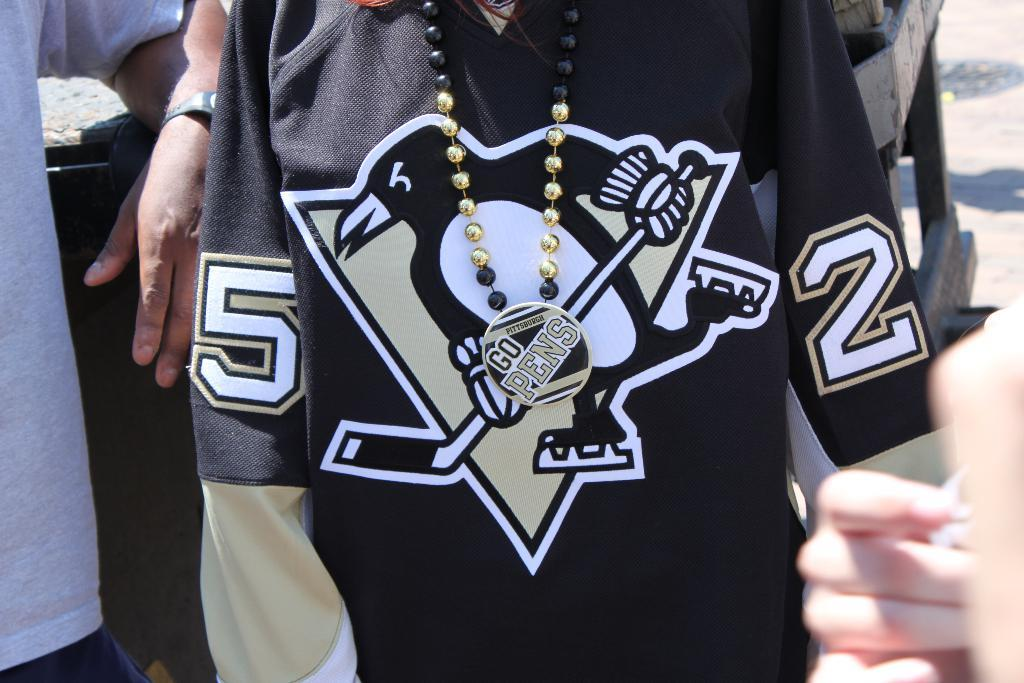Provide a one-sentence caption for the provided image. A button that reads "Go Pens" is pinned to a black Penguin jersey. 